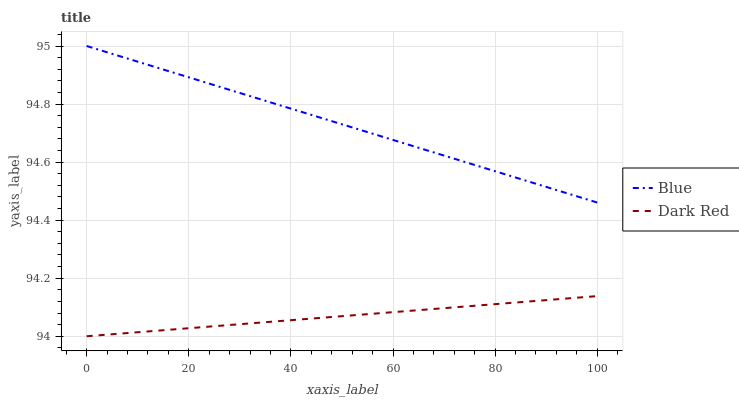Does Dark Red have the minimum area under the curve?
Answer yes or no. Yes. Does Blue have the maximum area under the curve?
Answer yes or no. Yes. Does Dark Red have the maximum area under the curve?
Answer yes or no. No. Is Dark Red the smoothest?
Answer yes or no. Yes. Is Blue the roughest?
Answer yes or no. Yes. Is Dark Red the roughest?
Answer yes or no. No. Does Dark Red have the lowest value?
Answer yes or no. Yes. Does Blue have the highest value?
Answer yes or no. Yes. Does Dark Red have the highest value?
Answer yes or no. No. Is Dark Red less than Blue?
Answer yes or no. Yes. Is Blue greater than Dark Red?
Answer yes or no. Yes. Does Dark Red intersect Blue?
Answer yes or no. No. 